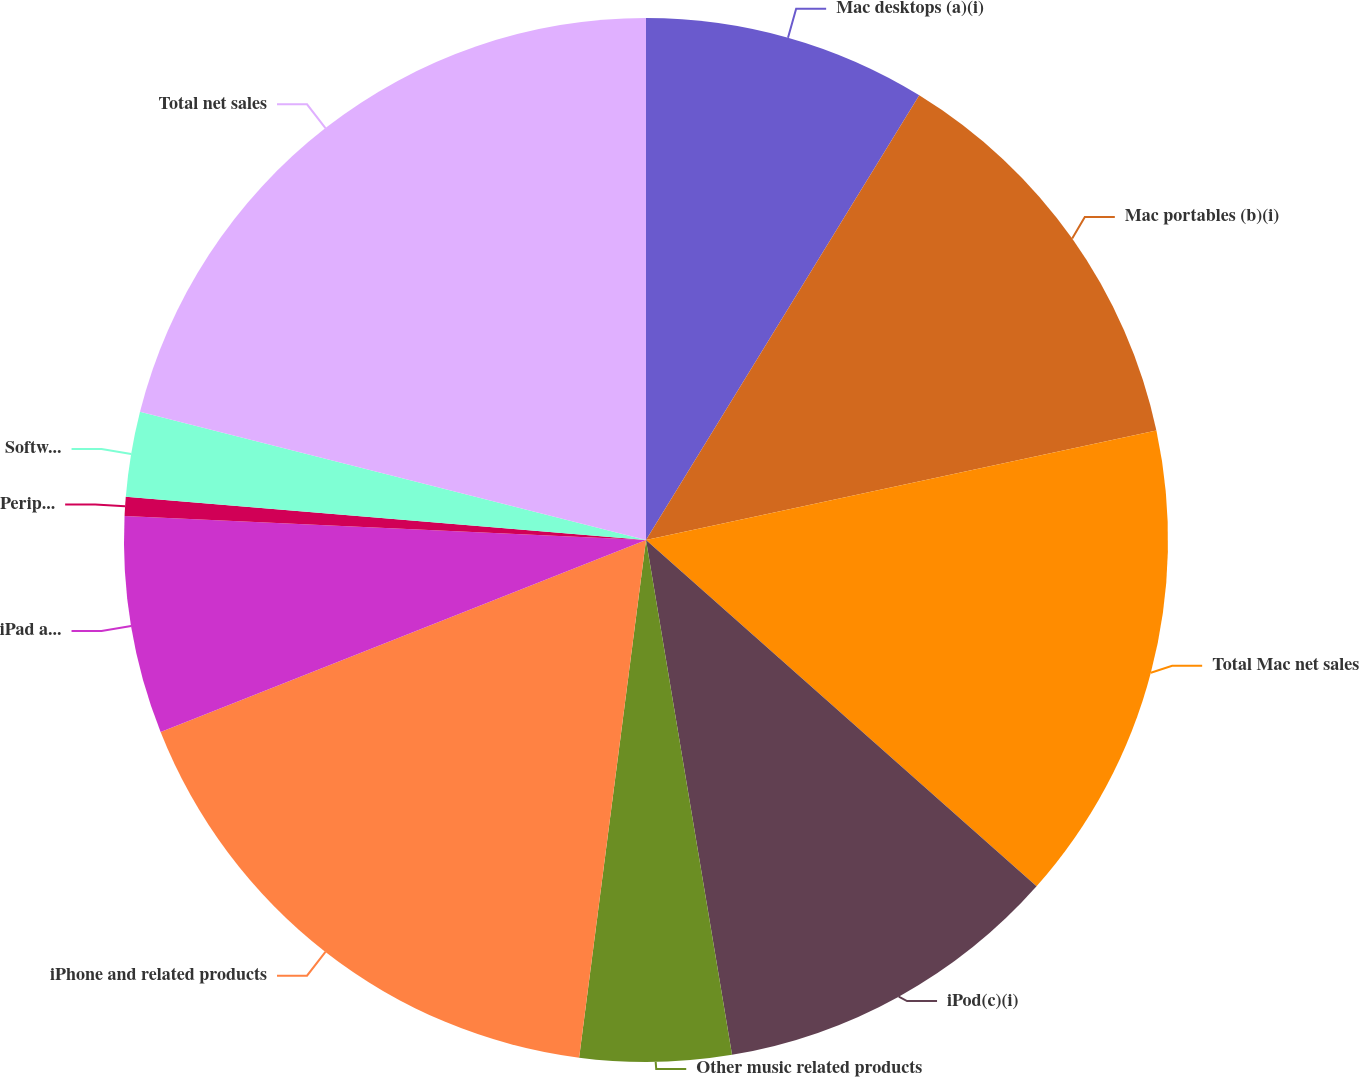Convert chart. <chart><loc_0><loc_0><loc_500><loc_500><pie_chart><fcel>Mac desktops (a)(i)<fcel>Mac portables (b)(i)<fcel>Total Mac net sales<fcel>iPod(c)(i)<fcel>Other music related products<fcel>iPhone and related products<fcel>iPad and related products and<fcel>Peripherals and other hardware<fcel>Software service and other net<fcel>Total net sales<nl><fcel>8.77%<fcel>12.87%<fcel>14.91%<fcel>10.82%<fcel>4.68%<fcel>16.96%<fcel>6.73%<fcel>0.59%<fcel>2.63%<fcel>21.05%<nl></chart> 